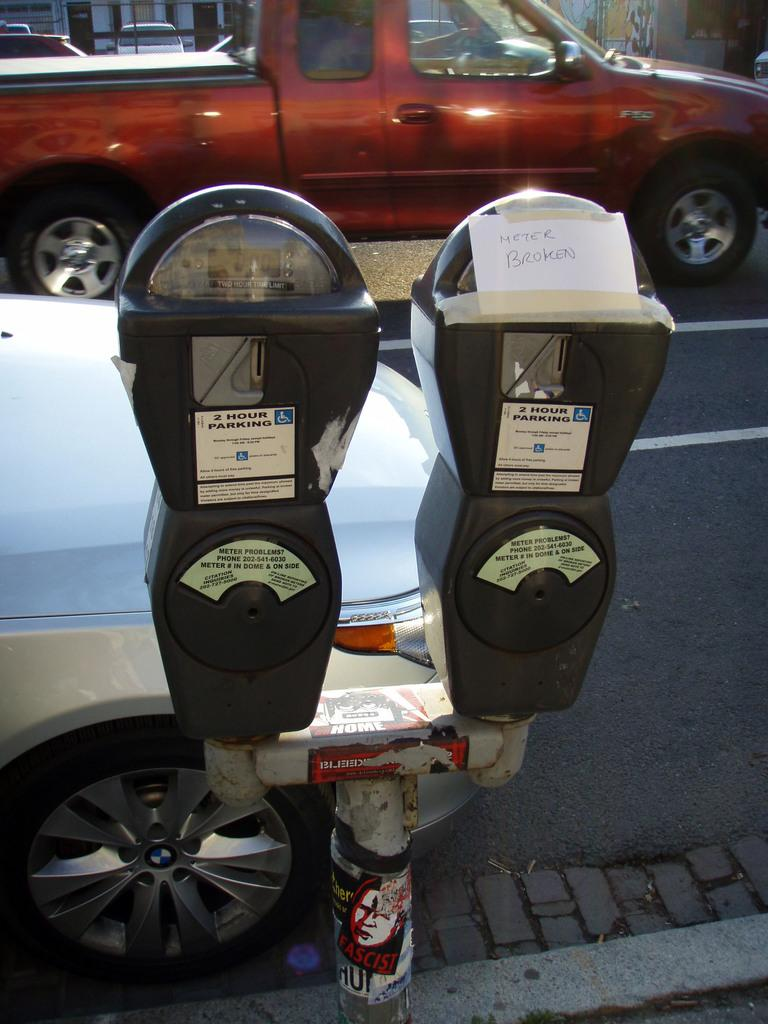<image>
Write a terse but informative summary of the picture. A parking meter has a note taped to it that says "Meter Broken" 